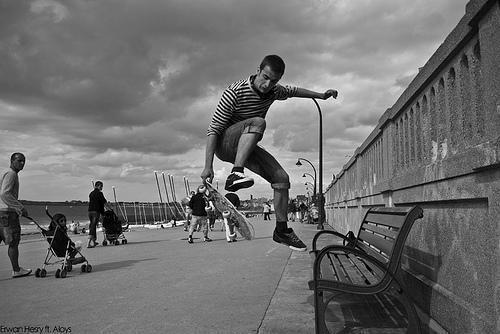How many strollers are there?
Give a very brief answer. 2. How many people are visible?
Give a very brief answer. 2. 